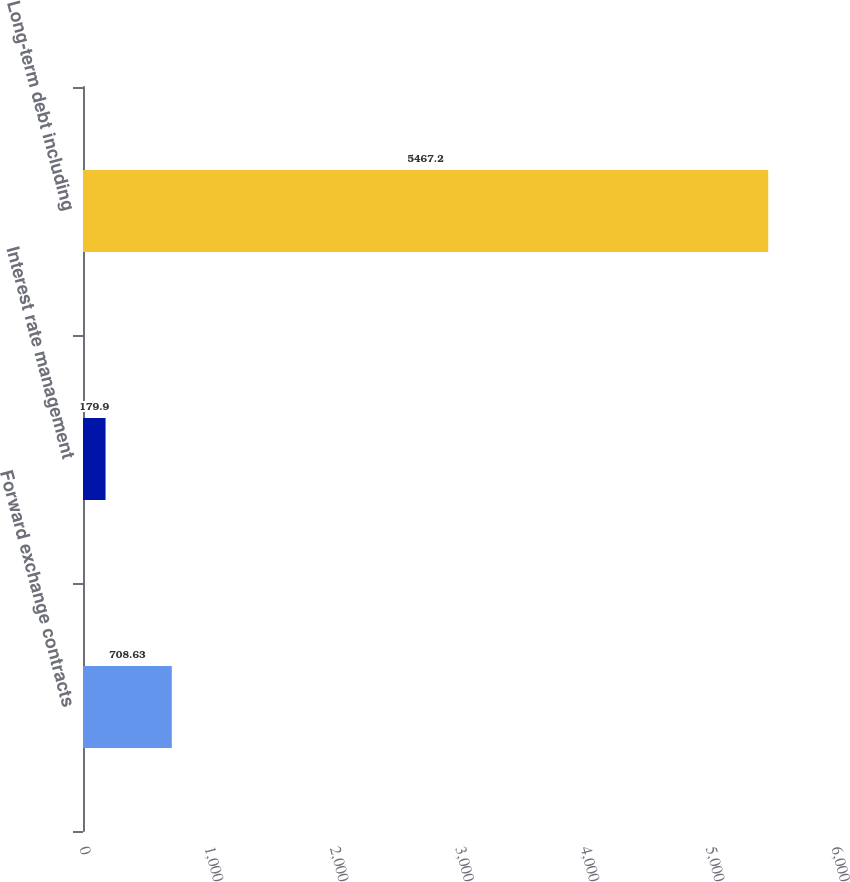Convert chart. <chart><loc_0><loc_0><loc_500><loc_500><bar_chart><fcel>Forward exchange contracts<fcel>Interest rate management<fcel>Long-term debt including<nl><fcel>708.63<fcel>179.9<fcel>5467.2<nl></chart> 